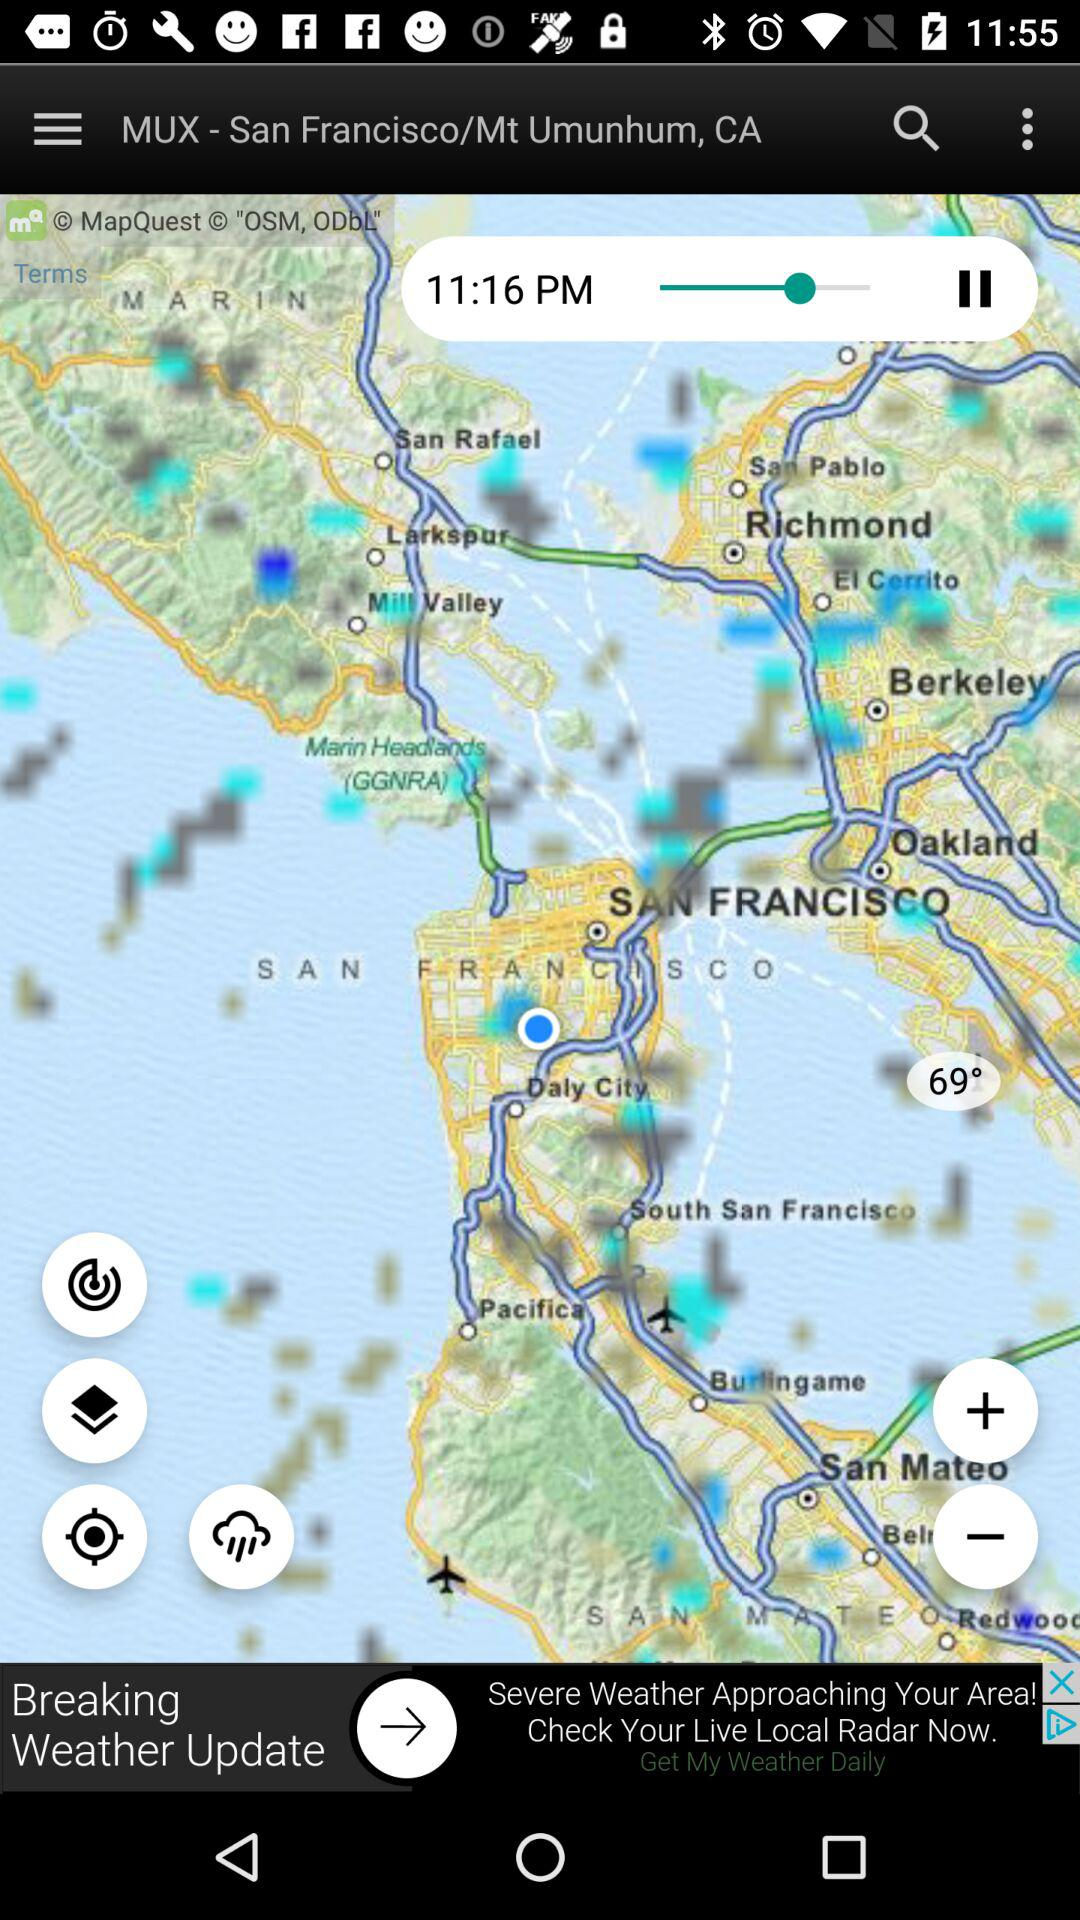What is the current location?
When the provided information is insufficient, respond with <no answer>. <no answer> 